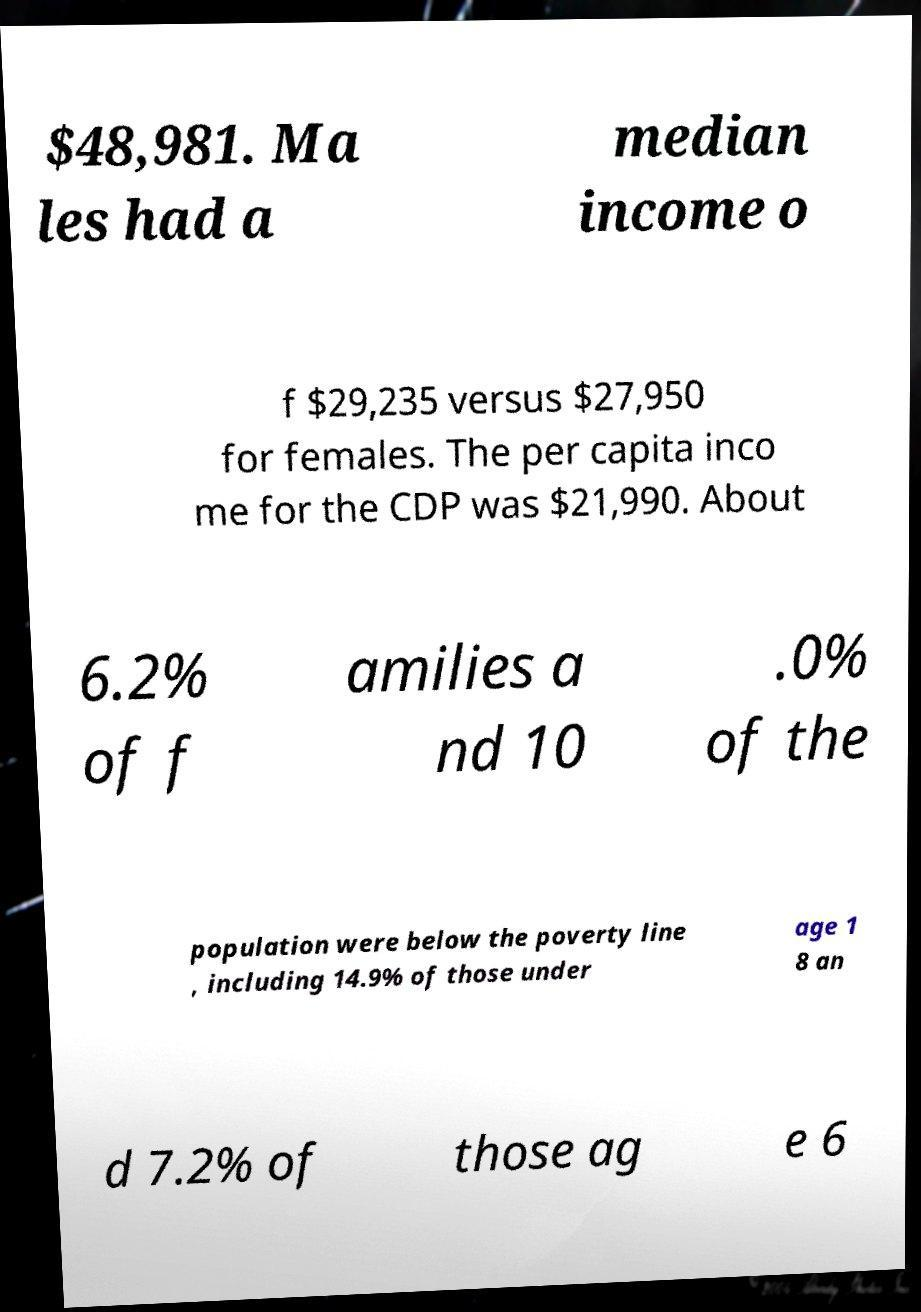For documentation purposes, I need the text within this image transcribed. Could you provide that? $48,981. Ma les had a median income o f $29,235 versus $27,950 for females. The per capita inco me for the CDP was $21,990. About 6.2% of f amilies a nd 10 .0% of the population were below the poverty line , including 14.9% of those under age 1 8 an d 7.2% of those ag e 6 